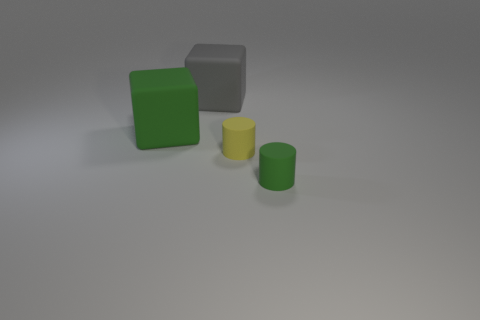What is the color of the object that is the same size as the gray block?
Keep it short and to the point. Green. What is the color of the other large object that is the same shape as the large gray matte thing?
Your answer should be very brief. Green. There is a matte thing that is to the right of the yellow rubber thing; is it the same size as the matte cube on the right side of the green cube?
Provide a short and direct response. No. Is the number of green matte things that are on the right side of the gray rubber block the same as the number of green rubber things behind the green cube?
Your response must be concise. No. Does the yellow matte thing have the same size as the green matte object that is to the left of the large gray block?
Your answer should be very brief. No. There is a object behind the green block; are there any big green blocks that are on the right side of it?
Your answer should be compact. No. Is there a red metal thing of the same shape as the tiny yellow rubber object?
Your answer should be compact. No. There is a yellow matte object to the right of the big object that is on the left side of the big gray thing; how many rubber cylinders are behind it?
Ensure brevity in your answer.  0. How many things are small things in front of the tiny yellow rubber cylinder or large rubber things on the right side of the big green thing?
Offer a very short reply. 2. Are there more gray rubber objects that are left of the large gray object than rubber blocks that are in front of the tiny green rubber thing?
Provide a short and direct response. No. 